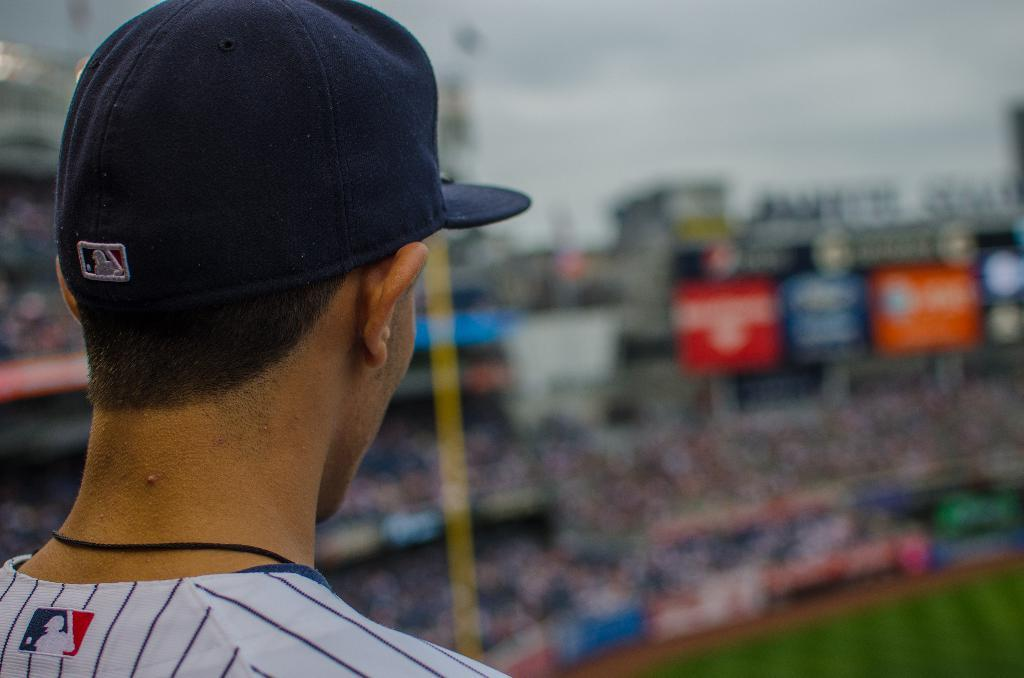What is the position of the person in the image? The person is standing on the left side of the image. What can be seen on the person's head? The person is wearing a black color cap. What is visible in the background of the image? The sky, clouds, a stadium, banners, and sign boards are present in the background of the image. What type of toy is the person playing with in the image? There is no toy present in the image; the person is simply standing and wearing a cap. 